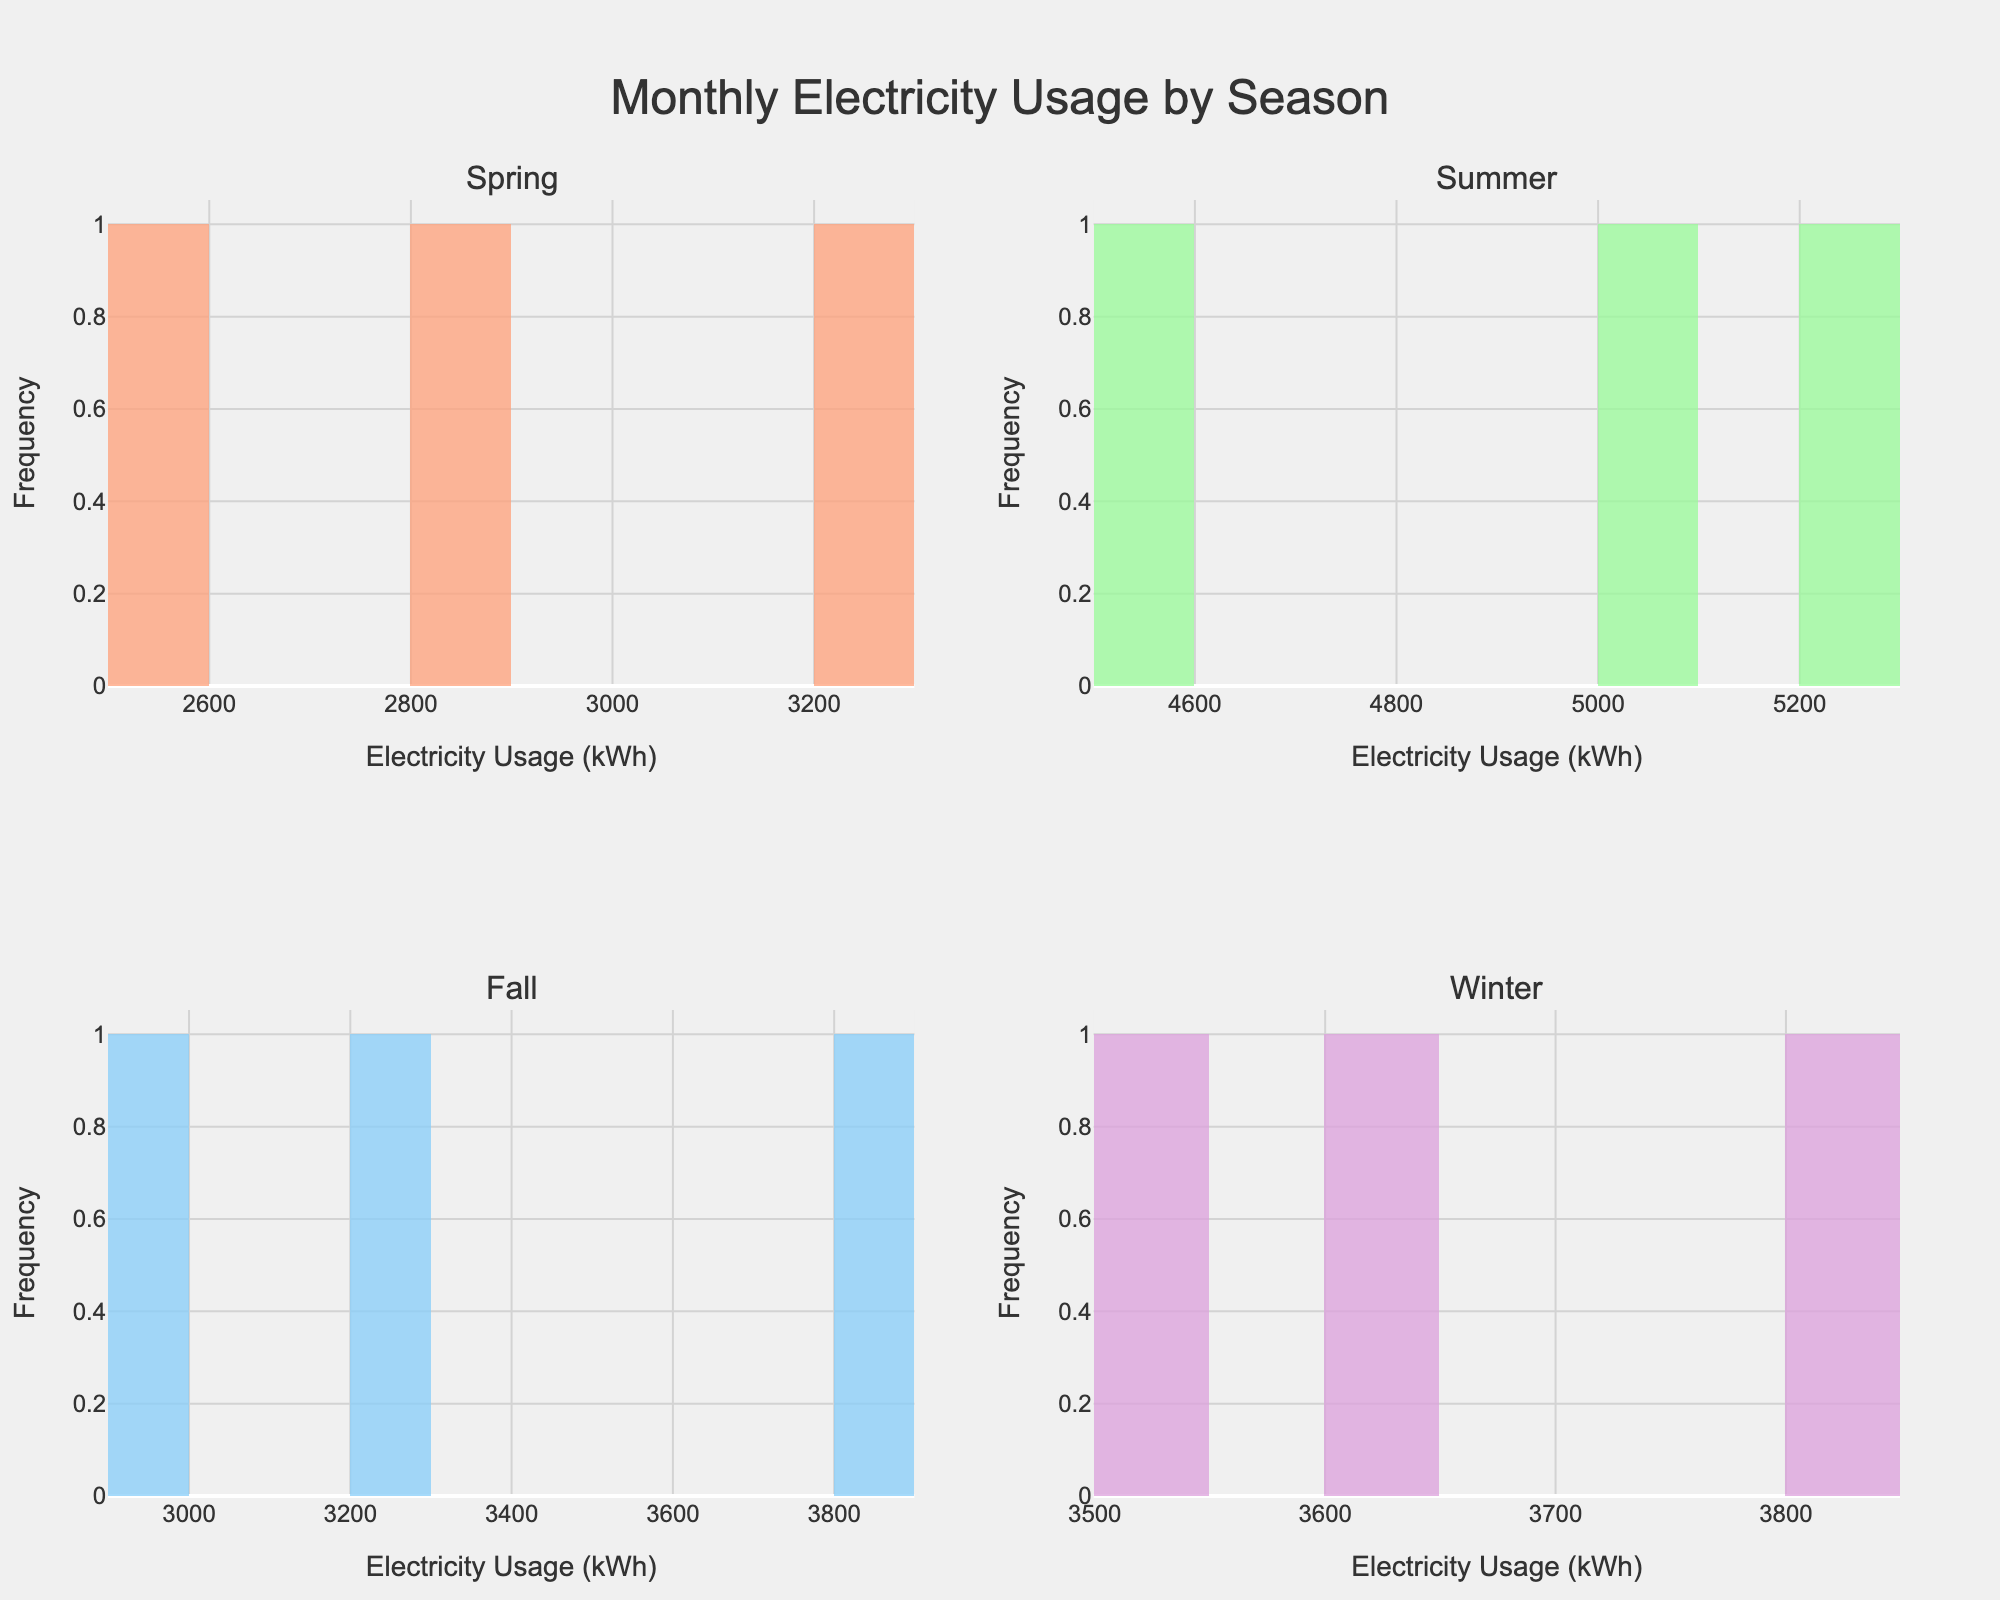what is the title of the figure? The title of the figure is centrally located at the top and usually written in larger font to indicate the main subject of the figure, which is "Monthly Electricity Usage by Season."
Answer: "Monthly Electricity Usage by Season." what are the axis titles for each subplot? Each subplot has an x-axis title "Electricity Usage (kWh)" and a y-axis title "Frequency," which are labeled to describe what each axis represents in the histograms.
Answer: "Electricity Usage (kWh)" and "Frequency." which season shows the highest electricity usage? Look at the histogram in each subplot, the season with the highest peak on the x-axis represents the highest electricity usage. Summer has the highest values that range up to 5200 kWh.
Answer: Summer how does the electricity usage in winter compare to fall? Compare the peaks of the histograms for Winter and Fall. Winter has slightly higher electricity usage with peaks around 3500 to 3800 kWh, while Fall peaks around 2900 to 3800 kWh.
Answer: Winter has slightly higher usage than Fall how many unique data points are there for each season? Count the bars in each histogram as each bar represents a unique data point for that season. Each season has three unique data points (months).
Answer: Three data points per season what is the range of electricity usage in spring? Identify the minimum and maximum electricity usage values in the Spring histogram. The range is calculated from the smallest to the largest value. Spring's use ranges from 2500 to 3200 kWh.
Answer: 2500 to 3200 kWh which season has the most consistent electricity usage? The consistency of electricity usage can be inferred by the narrowness of the histogram's peak. If the bars are close together and heights are similar, electricity usage is more consistent. Spring and Fall have more clustered bars, indicating consistent usage.
Answer: Spring or Fall in which month is the peak electricity usage observed, and what is the value? Look at the histogram for Summer as it shows the highest usage and find the tallest bar, representing the month of July with 5200 kWh.
Answer: July with 5200 kWh how does electricity usage in December compare to January? In the Winter histogram, compare the electricity usage in December (3500 kWh) and January (3800 kWh). January is slightly higher.
Answer: January is higher 